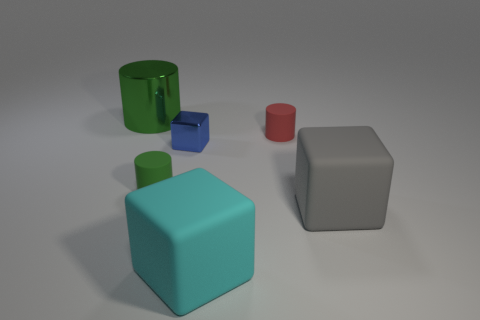Subtract all small red cylinders. How many cylinders are left? 2 Add 4 big metallic objects. How many objects exist? 10 Subtract 0 cyan cylinders. How many objects are left? 6 Subtract all green rubber things. Subtract all large red metal objects. How many objects are left? 5 Add 2 small blue things. How many small blue things are left? 3 Add 5 large yellow cylinders. How many large yellow cylinders exist? 5 